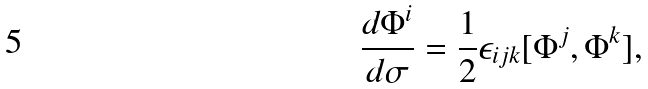<formula> <loc_0><loc_0><loc_500><loc_500>\frac { d \Phi ^ { i } } { d \sigma } = \frac { 1 } { 2 } \epsilon _ { i j k } [ \Phi ^ { j } , \Phi ^ { k } ] ,</formula> 